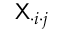<formula> <loc_0><loc_0><loc_500><loc_500>X _ { \cdot i \cdot j }</formula> 